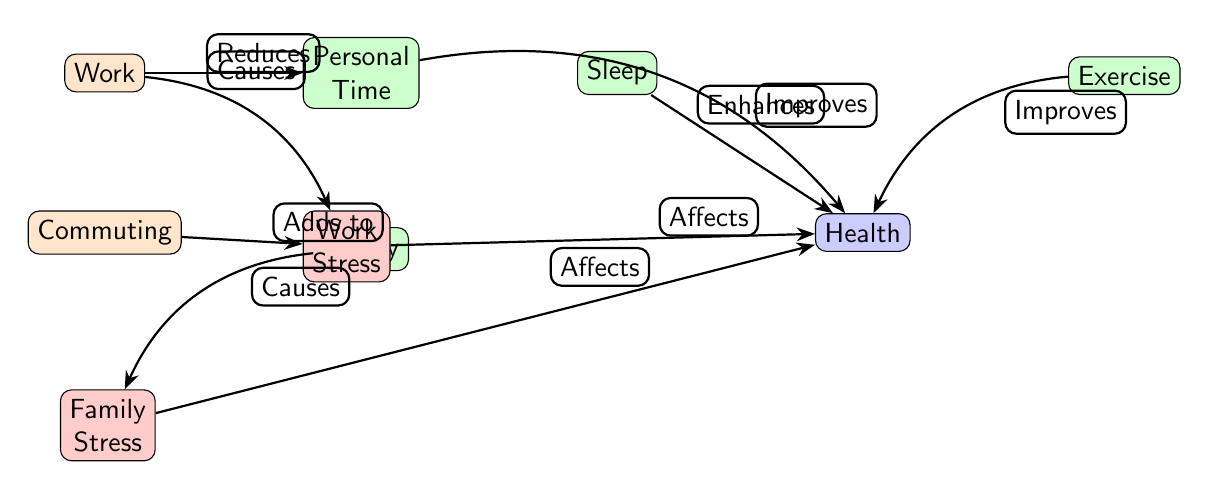What causes Work Stress? According to the diagram, Work Stress is caused by the Work node, as indicated by the directed edge labeled "Causes" from Work to Work Stress.
Answer: Work How many nodes represent personal time? The diagram has three nodes that represent personal time: Personal Time, Family, and Sleep.
Answer: 3 What enhances Health according to the diagram? The diagram shows that Sleep enhances Health, which is indicated by the edge labeled "Enhances" pointing from Sleep to Health.
Answer: Sleep Which factor adds to Work Stress? The diagram depicts that Commuting adds to Work Stress, as shown by the edge labeled "Adds to" pointing from Commuting to Work Stress.
Answer: Commuting How does Personal Time affect Health? The diagram indicates that Personal Time improves Health, as indicated by the edge labeled "Improves" pointing from Personal Time to Health.
Answer: Improves Which two sources cause Family Stress? The diagram illustrates that Family Stress is caused by the Family node, indicated by the edge labeled "Causes" pointing from Family to Family Stress, and by the Work node, indicated by a direct influence through stress effects.
Answer: Family What improves Health apart from Sleep? According to the diagram, both Exercise and Personal Time improve Health, as shown by edges leading into the Health node from these respective sources referencing improvement.
Answer: Exercise, Personal Time Which node reduces Personal Time? The diagram shows that Work reduces Personal Time, indicated by the directed edge labeled "Reduces" from Work to Personal Time.
Answer: Work Which type of stress affects Health? The diagram indicates that both Work Stress and Family Stress affect Health, as both of these stress nodes point to the Health node with edges labeled "Affects."
Answer: Work Stress, Family Stress 